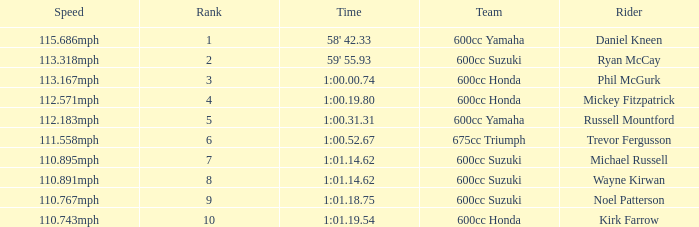How many ranks have michael russell as the rider? 7.0. 